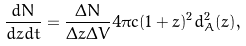Convert formula to latex. <formula><loc_0><loc_0><loc_500><loc_500>\frac { d N } { d z d t } = \frac { \Delta N } { \Delta z \Delta V } { 4 \pi c ( 1 + z ) ^ { 2 } d _ { A } ^ { 2 } ( z ) } ,</formula> 